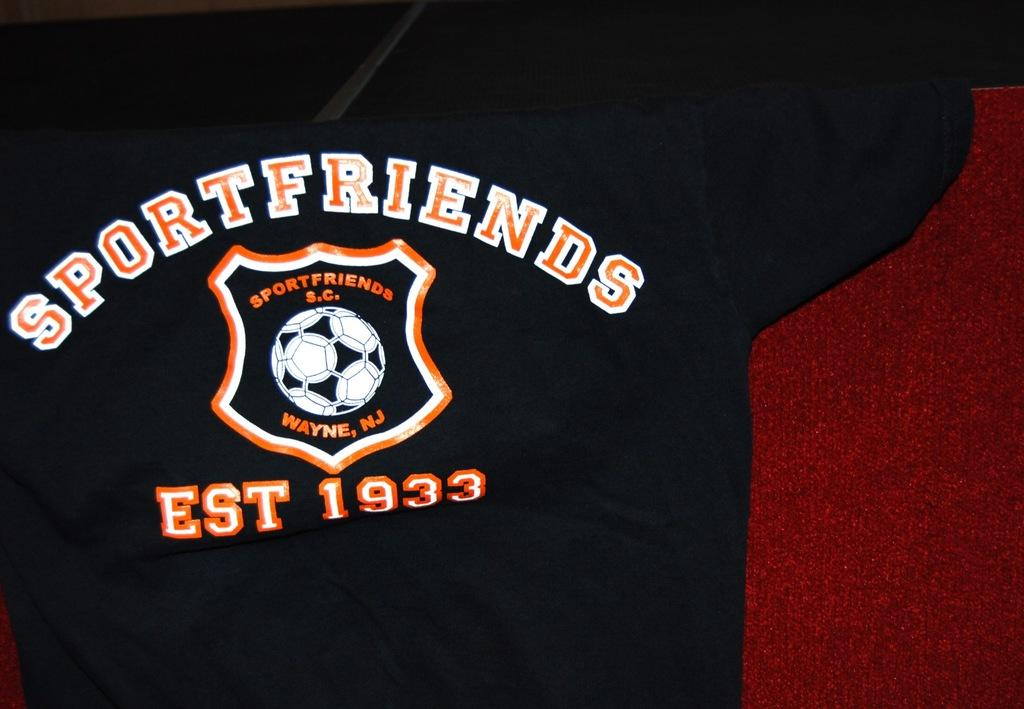Provide a one-sentence caption for the provided image. A black Sportfriends shirt has a white and orange soccer ball logo with text indicating an establishment date of 1933. 